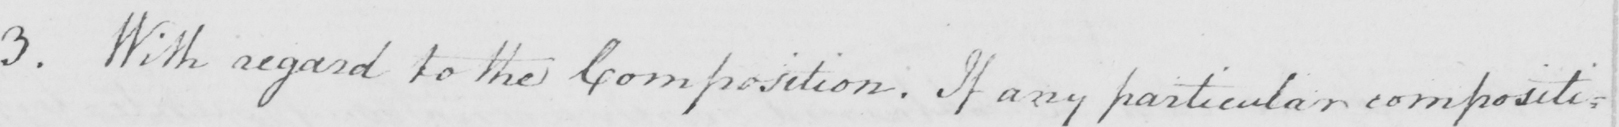Can you tell me what this handwritten text says? 3 . With regard to the Composition . If any particular compositi= 